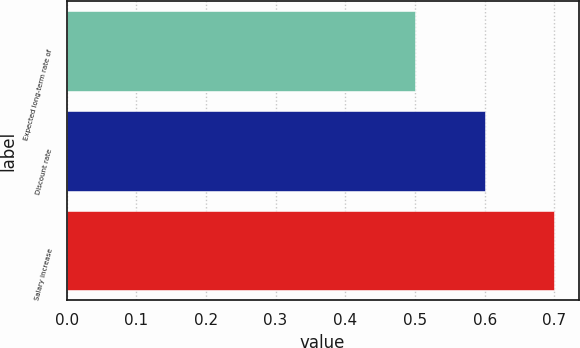Convert chart. <chart><loc_0><loc_0><loc_500><loc_500><bar_chart><fcel>Expected long-term rate of<fcel>Discount rate<fcel>Salary increase<nl><fcel>0.5<fcel>0.6<fcel>0.7<nl></chart> 